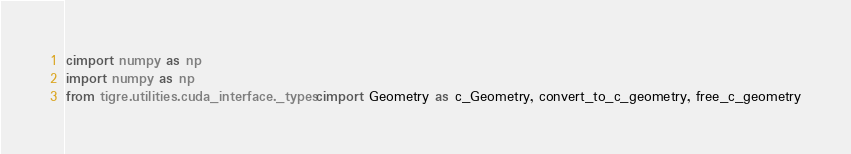Convert code to text. <code><loc_0><loc_0><loc_500><loc_500><_Cython_>cimport numpy as np
import numpy as np
from tigre.utilities.cuda_interface._types cimport Geometry as c_Geometry, convert_to_c_geometry, free_c_geometry</code> 